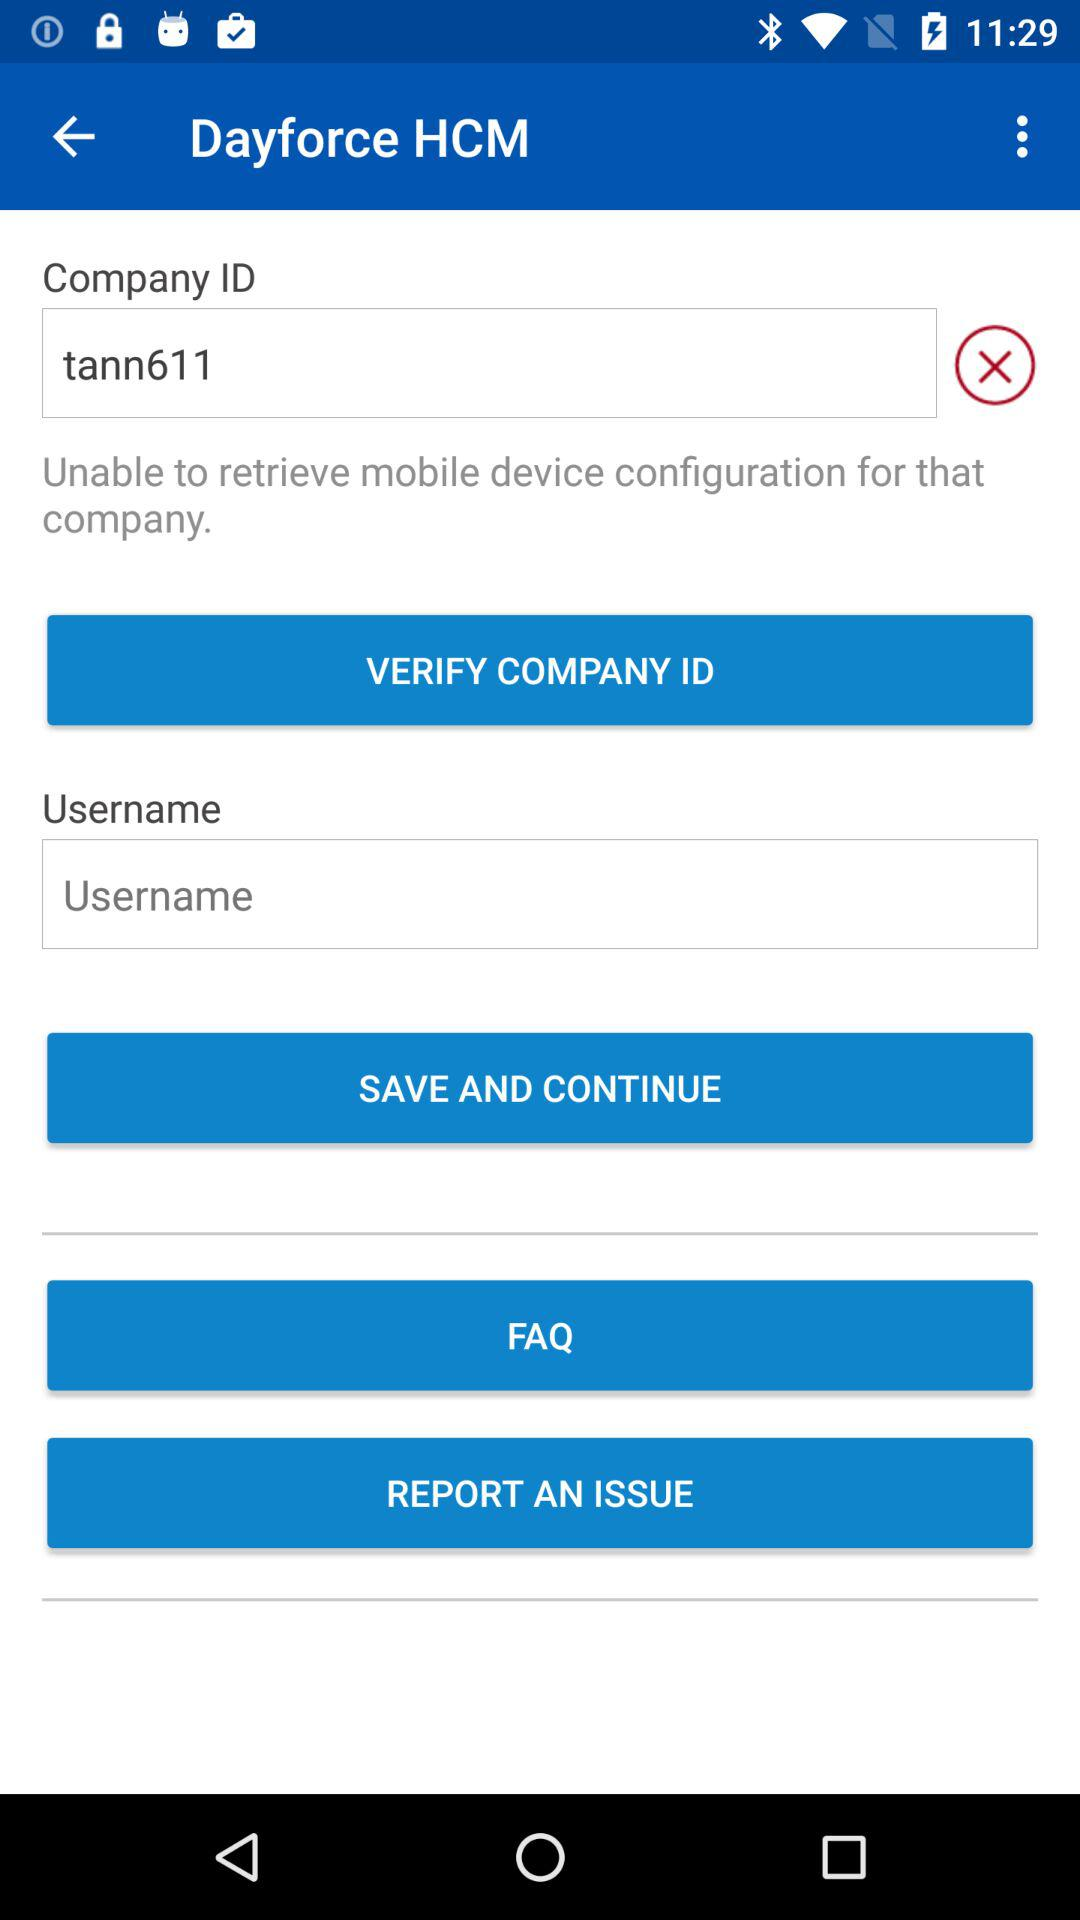What is the given company ID? The given company ID is "tann611". 